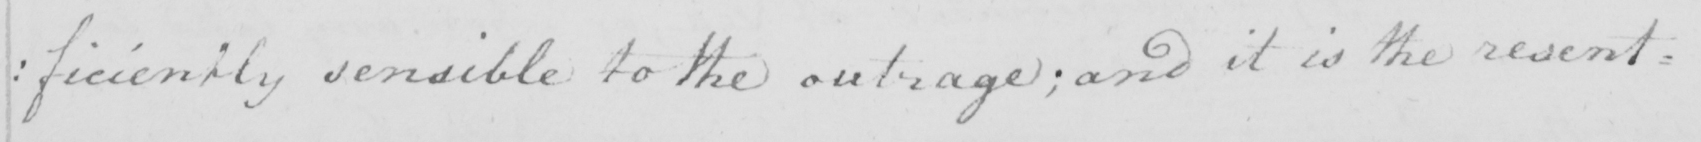What is written in this line of handwriting? : ficiently sensible to the outrage ; and it is the resent= 